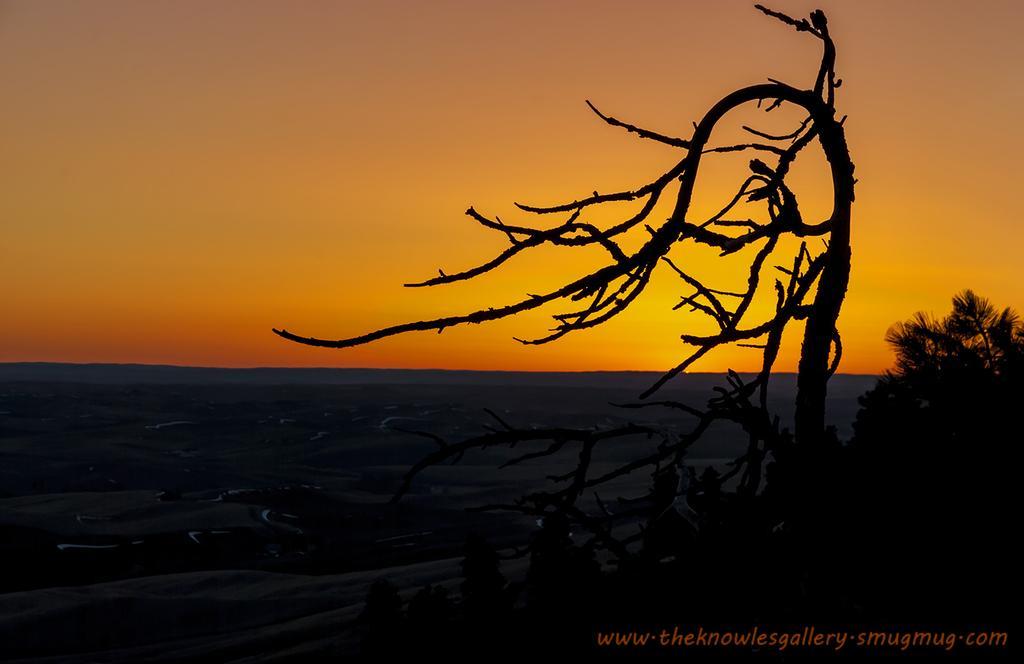Can you describe this image briefly? This image seems like an edited image. At the bottom there is a text. In the middle there are trees, branches, water, sky. 